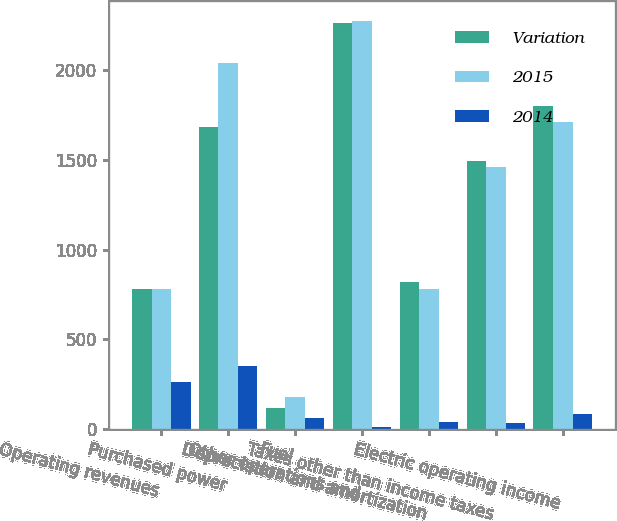Convert chart. <chart><loc_0><loc_0><loc_500><loc_500><stacked_bar_chart><ecel><fcel>Operating revenues<fcel>Purchased power<fcel>Fuel<fcel>Other operations and<fcel>Depreciation and amortization<fcel>Taxes other than income taxes<fcel>Electric operating income<nl><fcel>Variation<fcel>781<fcel>1684<fcel>118<fcel>2259<fcel>820<fcel>1493<fcel>1798<nl><fcel>2015<fcel>781<fcel>2036<fcel>180<fcel>2270<fcel>781<fcel>1458<fcel>1712<nl><fcel>2014<fcel>265<fcel>352<fcel>62<fcel>11<fcel>39<fcel>35<fcel>86<nl></chart> 